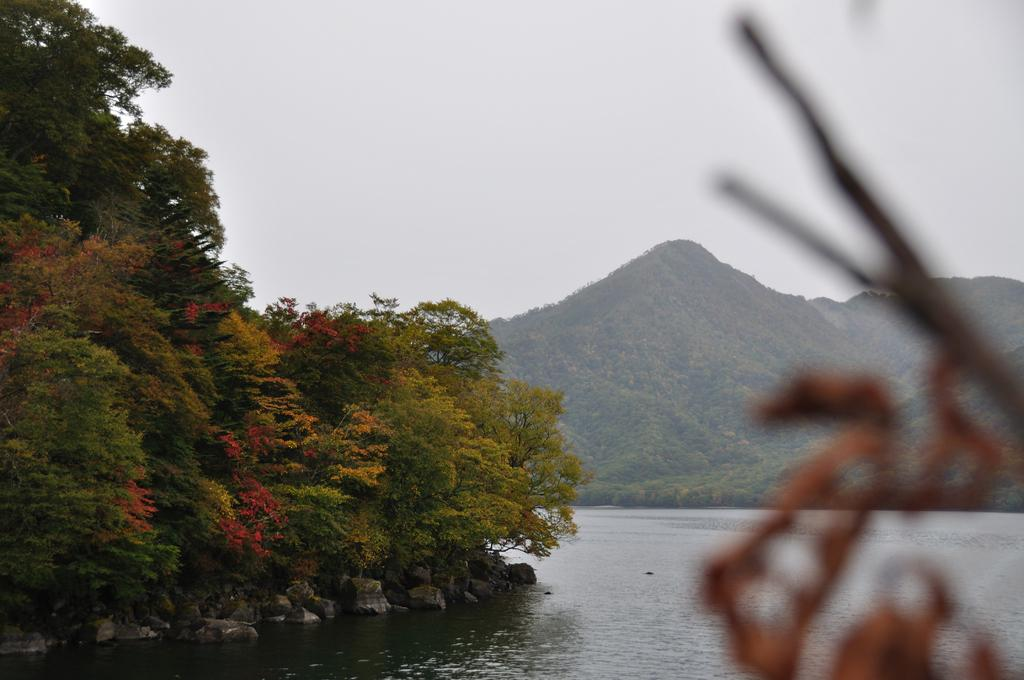What type of natural elements can be seen in the image? There are trees, hills, water, and rocks visible in the image. What is the condition of the sky in the image? The sky is cloudy in the image. What type of amusement can be seen in the image? There is no amusement present in the image; it features natural elements such as trees, hills, water, rocks, and a cloudy sky. 